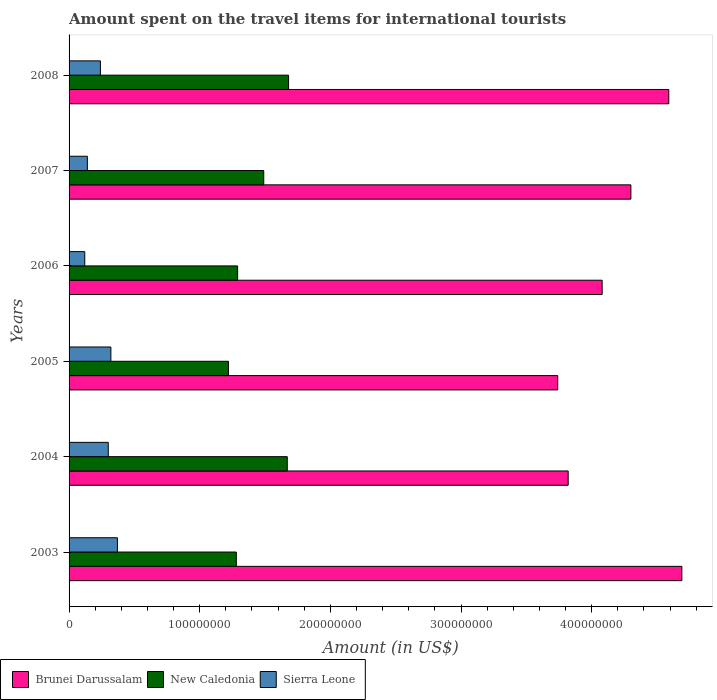How many groups of bars are there?
Provide a short and direct response. 6. How many bars are there on the 4th tick from the bottom?
Provide a succinct answer. 3. What is the amount spent on the travel items for international tourists in New Caledonia in 2006?
Keep it short and to the point. 1.29e+08. Across all years, what is the maximum amount spent on the travel items for international tourists in New Caledonia?
Keep it short and to the point. 1.68e+08. Across all years, what is the minimum amount spent on the travel items for international tourists in New Caledonia?
Make the answer very short. 1.22e+08. In which year was the amount spent on the travel items for international tourists in Sierra Leone minimum?
Your answer should be compact. 2006. What is the total amount spent on the travel items for international tourists in New Caledonia in the graph?
Offer a very short reply. 8.63e+08. What is the difference between the amount spent on the travel items for international tourists in Brunei Darussalam in 2003 and that in 2004?
Ensure brevity in your answer.  8.70e+07. What is the difference between the amount spent on the travel items for international tourists in New Caledonia in 2004 and the amount spent on the travel items for international tourists in Brunei Darussalam in 2003?
Offer a very short reply. -3.02e+08. What is the average amount spent on the travel items for international tourists in Brunei Darussalam per year?
Make the answer very short. 4.20e+08. In the year 2007, what is the difference between the amount spent on the travel items for international tourists in New Caledonia and amount spent on the travel items for international tourists in Brunei Darussalam?
Your answer should be very brief. -2.81e+08. What is the ratio of the amount spent on the travel items for international tourists in New Caledonia in 2006 to that in 2007?
Make the answer very short. 0.87. Is the amount spent on the travel items for international tourists in New Caledonia in 2005 less than that in 2006?
Make the answer very short. Yes. Is the difference between the amount spent on the travel items for international tourists in New Caledonia in 2006 and 2007 greater than the difference between the amount spent on the travel items for international tourists in Brunei Darussalam in 2006 and 2007?
Your answer should be compact. Yes. What is the difference between the highest and the lowest amount spent on the travel items for international tourists in Sierra Leone?
Keep it short and to the point. 2.50e+07. Is the sum of the amount spent on the travel items for international tourists in New Caledonia in 2007 and 2008 greater than the maximum amount spent on the travel items for international tourists in Brunei Darussalam across all years?
Your answer should be compact. No. What does the 3rd bar from the top in 2005 represents?
Ensure brevity in your answer.  Brunei Darussalam. What does the 1st bar from the bottom in 2003 represents?
Provide a succinct answer. Brunei Darussalam. Is it the case that in every year, the sum of the amount spent on the travel items for international tourists in Sierra Leone and amount spent on the travel items for international tourists in New Caledonia is greater than the amount spent on the travel items for international tourists in Brunei Darussalam?
Make the answer very short. No. Are the values on the major ticks of X-axis written in scientific E-notation?
Offer a very short reply. No. Does the graph contain any zero values?
Make the answer very short. No. Does the graph contain grids?
Provide a succinct answer. No. How many legend labels are there?
Keep it short and to the point. 3. What is the title of the graph?
Provide a short and direct response. Amount spent on the travel items for international tourists. What is the label or title of the X-axis?
Your response must be concise. Amount (in US$). What is the label or title of the Y-axis?
Ensure brevity in your answer.  Years. What is the Amount (in US$) in Brunei Darussalam in 2003?
Provide a succinct answer. 4.69e+08. What is the Amount (in US$) of New Caledonia in 2003?
Provide a short and direct response. 1.28e+08. What is the Amount (in US$) of Sierra Leone in 2003?
Make the answer very short. 3.70e+07. What is the Amount (in US$) in Brunei Darussalam in 2004?
Your answer should be very brief. 3.82e+08. What is the Amount (in US$) of New Caledonia in 2004?
Your response must be concise. 1.67e+08. What is the Amount (in US$) of Sierra Leone in 2004?
Your answer should be compact. 3.00e+07. What is the Amount (in US$) of Brunei Darussalam in 2005?
Your response must be concise. 3.74e+08. What is the Amount (in US$) in New Caledonia in 2005?
Your answer should be compact. 1.22e+08. What is the Amount (in US$) of Sierra Leone in 2005?
Ensure brevity in your answer.  3.20e+07. What is the Amount (in US$) in Brunei Darussalam in 2006?
Keep it short and to the point. 4.08e+08. What is the Amount (in US$) of New Caledonia in 2006?
Your response must be concise. 1.29e+08. What is the Amount (in US$) in Sierra Leone in 2006?
Your response must be concise. 1.20e+07. What is the Amount (in US$) in Brunei Darussalam in 2007?
Your response must be concise. 4.30e+08. What is the Amount (in US$) of New Caledonia in 2007?
Offer a terse response. 1.49e+08. What is the Amount (in US$) of Sierra Leone in 2007?
Offer a terse response. 1.40e+07. What is the Amount (in US$) of Brunei Darussalam in 2008?
Offer a terse response. 4.59e+08. What is the Amount (in US$) of New Caledonia in 2008?
Give a very brief answer. 1.68e+08. What is the Amount (in US$) of Sierra Leone in 2008?
Ensure brevity in your answer.  2.40e+07. Across all years, what is the maximum Amount (in US$) of Brunei Darussalam?
Ensure brevity in your answer.  4.69e+08. Across all years, what is the maximum Amount (in US$) of New Caledonia?
Your response must be concise. 1.68e+08. Across all years, what is the maximum Amount (in US$) of Sierra Leone?
Offer a very short reply. 3.70e+07. Across all years, what is the minimum Amount (in US$) of Brunei Darussalam?
Offer a very short reply. 3.74e+08. Across all years, what is the minimum Amount (in US$) of New Caledonia?
Provide a succinct answer. 1.22e+08. Across all years, what is the minimum Amount (in US$) of Sierra Leone?
Your answer should be very brief. 1.20e+07. What is the total Amount (in US$) in Brunei Darussalam in the graph?
Provide a short and direct response. 2.52e+09. What is the total Amount (in US$) in New Caledonia in the graph?
Offer a terse response. 8.63e+08. What is the total Amount (in US$) of Sierra Leone in the graph?
Keep it short and to the point. 1.49e+08. What is the difference between the Amount (in US$) of Brunei Darussalam in 2003 and that in 2004?
Offer a very short reply. 8.70e+07. What is the difference between the Amount (in US$) in New Caledonia in 2003 and that in 2004?
Ensure brevity in your answer.  -3.90e+07. What is the difference between the Amount (in US$) of Sierra Leone in 2003 and that in 2004?
Keep it short and to the point. 7.00e+06. What is the difference between the Amount (in US$) in Brunei Darussalam in 2003 and that in 2005?
Offer a very short reply. 9.50e+07. What is the difference between the Amount (in US$) of Brunei Darussalam in 2003 and that in 2006?
Provide a succinct answer. 6.10e+07. What is the difference between the Amount (in US$) in New Caledonia in 2003 and that in 2006?
Ensure brevity in your answer.  -1.00e+06. What is the difference between the Amount (in US$) of Sierra Leone in 2003 and that in 2006?
Offer a terse response. 2.50e+07. What is the difference between the Amount (in US$) of Brunei Darussalam in 2003 and that in 2007?
Offer a very short reply. 3.90e+07. What is the difference between the Amount (in US$) in New Caledonia in 2003 and that in 2007?
Make the answer very short. -2.10e+07. What is the difference between the Amount (in US$) of Sierra Leone in 2003 and that in 2007?
Your response must be concise. 2.30e+07. What is the difference between the Amount (in US$) of Brunei Darussalam in 2003 and that in 2008?
Offer a very short reply. 1.00e+07. What is the difference between the Amount (in US$) in New Caledonia in 2003 and that in 2008?
Your answer should be very brief. -4.00e+07. What is the difference between the Amount (in US$) of Sierra Leone in 2003 and that in 2008?
Your answer should be compact. 1.30e+07. What is the difference between the Amount (in US$) of Brunei Darussalam in 2004 and that in 2005?
Offer a terse response. 8.00e+06. What is the difference between the Amount (in US$) in New Caledonia in 2004 and that in 2005?
Give a very brief answer. 4.50e+07. What is the difference between the Amount (in US$) of Brunei Darussalam in 2004 and that in 2006?
Give a very brief answer. -2.60e+07. What is the difference between the Amount (in US$) in New Caledonia in 2004 and that in 2006?
Provide a succinct answer. 3.80e+07. What is the difference between the Amount (in US$) in Sierra Leone in 2004 and that in 2006?
Keep it short and to the point. 1.80e+07. What is the difference between the Amount (in US$) of Brunei Darussalam in 2004 and that in 2007?
Your response must be concise. -4.80e+07. What is the difference between the Amount (in US$) in New Caledonia in 2004 and that in 2007?
Offer a terse response. 1.80e+07. What is the difference between the Amount (in US$) of Sierra Leone in 2004 and that in 2007?
Offer a very short reply. 1.60e+07. What is the difference between the Amount (in US$) of Brunei Darussalam in 2004 and that in 2008?
Your answer should be compact. -7.70e+07. What is the difference between the Amount (in US$) in New Caledonia in 2004 and that in 2008?
Give a very brief answer. -1.00e+06. What is the difference between the Amount (in US$) of Sierra Leone in 2004 and that in 2008?
Make the answer very short. 6.00e+06. What is the difference between the Amount (in US$) in Brunei Darussalam in 2005 and that in 2006?
Provide a succinct answer. -3.40e+07. What is the difference between the Amount (in US$) in New Caledonia in 2005 and that in 2006?
Give a very brief answer. -7.00e+06. What is the difference between the Amount (in US$) in Sierra Leone in 2005 and that in 2006?
Your response must be concise. 2.00e+07. What is the difference between the Amount (in US$) in Brunei Darussalam in 2005 and that in 2007?
Your answer should be compact. -5.60e+07. What is the difference between the Amount (in US$) in New Caledonia in 2005 and that in 2007?
Offer a terse response. -2.70e+07. What is the difference between the Amount (in US$) of Sierra Leone in 2005 and that in 2007?
Ensure brevity in your answer.  1.80e+07. What is the difference between the Amount (in US$) in Brunei Darussalam in 2005 and that in 2008?
Offer a very short reply. -8.50e+07. What is the difference between the Amount (in US$) in New Caledonia in 2005 and that in 2008?
Give a very brief answer. -4.60e+07. What is the difference between the Amount (in US$) of Sierra Leone in 2005 and that in 2008?
Provide a short and direct response. 8.00e+06. What is the difference between the Amount (in US$) of Brunei Darussalam in 2006 and that in 2007?
Your answer should be compact. -2.20e+07. What is the difference between the Amount (in US$) in New Caledonia in 2006 and that in 2007?
Offer a terse response. -2.00e+07. What is the difference between the Amount (in US$) in Sierra Leone in 2006 and that in 2007?
Offer a terse response. -2.00e+06. What is the difference between the Amount (in US$) of Brunei Darussalam in 2006 and that in 2008?
Offer a very short reply. -5.10e+07. What is the difference between the Amount (in US$) in New Caledonia in 2006 and that in 2008?
Provide a short and direct response. -3.90e+07. What is the difference between the Amount (in US$) of Sierra Leone in 2006 and that in 2008?
Offer a terse response. -1.20e+07. What is the difference between the Amount (in US$) of Brunei Darussalam in 2007 and that in 2008?
Make the answer very short. -2.90e+07. What is the difference between the Amount (in US$) in New Caledonia in 2007 and that in 2008?
Provide a succinct answer. -1.90e+07. What is the difference between the Amount (in US$) of Sierra Leone in 2007 and that in 2008?
Give a very brief answer. -1.00e+07. What is the difference between the Amount (in US$) of Brunei Darussalam in 2003 and the Amount (in US$) of New Caledonia in 2004?
Provide a short and direct response. 3.02e+08. What is the difference between the Amount (in US$) in Brunei Darussalam in 2003 and the Amount (in US$) in Sierra Leone in 2004?
Keep it short and to the point. 4.39e+08. What is the difference between the Amount (in US$) of New Caledonia in 2003 and the Amount (in US$) of Sierra Leone in 2004?
Provide a short and direct response. 9.80e+07. What is the difference between the Amount (in US$) of Brunei Darussalam in 2003 and the Amount (in US$) of New Caledonia in 2005?
Provide a short and direct response. 3.47e+08. What is the difference between the Amount (in US$) in Brunei Darussalam in 2003 and the Amount (in US$) in Sierra Leone in 2005?
Keep it short and to the point. 4.37e+08. What is the difference between the Amount (in US$) in New Caledonia in 2003 and the Amount (in US$) in Sierra Leone in 2005?
Your answer should be compact. 9.60e+07. What is the difference between the Amount (in US$) in Brunei Darussalam in 2003 and the Amount (in US$) in New Caledonia in 2006?
Give a very brief answer. 3.40e+08. What is the difference between the Amount (in US$) in Brunei Darussalam in 2003 and the Amount (in US$) in Sierra Leone in 2006?
Make the answer very short. 4.57e+08. What is the difference between the Amount (in US$) in New Caledonia in 2003 and the Amount (in US$) in Sierra Leone in 2006?
Provide a short and direct response. 1.16e+08. What is the difference between the Amount (in US$) in Brunei Darussalam in 2003 and the Amount (in US$) in New Caledonia in 2007?
Provide a short and direct response. 3.20e+08. What is the difference between the Amount (in US$) of Brunei Darussalam in 2003 and the Amount (in US$) of Sierra Leone in 2007?
Offer a very short reply. 4.55e+08. What is the difference between the Amount (in US$) of New Caledonia in 2003 and the Amount (in US$) of Sierra Leone in 2007?
Provide a succinct answer. 1.14e+08. What is the difference between the Amount (in US$) of Brunei Darussalam in 2003 and the Amount (in US$) of New Caledonia in 2008?
Keep it short and to the point. 3.01e+08. What is the difference between the Amount (in US$) in Brunei Darussalam in 2003 and the Amount (in US$) in Sierra Leone in 2008?
Keep it short and to the point. 4.45e+08. What is the difference between the Amount (in US$) of New Caledonia in 2003 and the Amount (in US$) of Sierra Leone in 2008?
Your response must be concise. 1.04e+08. What is the difference between the Amount (in US$) in Brunei Darussalam in 2004 and the Amount (in US$) in New Caledonia in 2005?
Provide a succinct answer. 2.60e+08. What is the difference between the Amount (in US$) in Brunei Darussalam in 2004 and the Amount (in US$) in Sierra Leone in 2005?
Your answer should be very brief. 3.50e+08. What is the difference between the Amount (in US$) in New Caledonia in 2004 and the Amount (in US$) in Sierra Leone in 2005?
Make the answer very short. 1.35e+08. What is the difference between the Amount (in US$) in Brunei Darussalam in 2004 and the Amount (in US$) in New Caledonia in 2006?
Give a very brief answer. 2.53e+08. What is the difference between the Amount (in US$) of Brunei Darussalam in 2004 and the Amount (in US$) of Sierra Leone in 2006?
Give a very brief answer. 3.70e+08. What is the difference between the Amount (in US$) of New Caledonia in 2004 and the Amount (in US$) of Sierra Leone in 2006?
Your answer should be compact. 1.55e+08. What is the difference between the Amount (in US$) of Brunei Darussalam in 2004 and the Amount (in US$) of New Caledonia in 2007?
Offer a very short reply. 2.33e+08. What is the difference between the Amount (in US$) in Brunei Darussalam in 2004 and the Amount (in US$) in Sierra Leone in 2007?
Ensure brevity in your answer.  3.68e+08. What is the difference between the Amount (in US$) of New Caledonia in 2004 and the Amount (in US$) of Sierra Leone in 2007?
Make the answer very short. 1.53e+08. What is the difference between the Amount (in US$) in Brunei Darussalam in 2004 and the Amount (in US$) in New Caledonia in 2008?
Offer a very short reply. 2.14e+08. What is the difference between the Amount (in US$) of Brunei Darussalam in 2004 and the Amount (in US$) of Sierra Leone in 2008?
Provide a succinct answer. 3.58e+08. What is the difference between the Amount (in US$) in New Caledonia in 2004 and the Amount (in US$) in Sierra Leone in 2008?
Your answer should be very brief. 1.43e+08. What is the difference between the Amount (in US$) of Brunei Darussalam in 2005 and the Amount (in US$) of New Caledonia in 2006?
Ensure brevity in your answer.  2.45e+08. What is the difference between the Amount (in US$) in Brunei Darussalam in 2005 and the Amount (in US$) in Sierra Leone in 2006?
Offer a terse response. 3.62e+08. What is the difference between the Amount (in US$) in New Caledonia in 2005 and the Amount (in US$) in Sierra Leone in 2006?
Provide a short and direct response. 1.10e+08. What is the difference between the Amount (in US$) of Brunei Darussalam in 2005 and the Amount (in US$) of New Caledonia in 2007?
Your answer should be compact. 2.25e+08. What is the difference between the Amount (in US$) of Brunei Darussalam in 2005 and the Amount (in US$) of Sierra Leone in 2007?
Your response must be concise. 3.60e+08. What is the difference between the Amount (in US$) in New Caledonia in 2005 and the Amount (in US$) in Sierra Leone in 2007?
Your response must be concise. 1.08e+08. What is the difference between the Amount (in US$) in Brunei Darussalam in 2005 and the Amount (in US$) in New Caledonia in 2008?
Provide a succinct answer. 2.06e+08. What is the difference between the Amount (in US$) of Brunei Darussalam in 2005 and the Amount (in US$) of Sierra Leone in 2008?
Offer a very short reply. 3.50e+08. What is the difference between the Amount (in US$) in New Caledonia in 2005 and the Amount (in US$) in Sierra Leone in 2008?
Your answer should be compact. 9.80e+07. What is the difference between the Amount (in US$) of Brunei Darussalam in 2006 and the Amount (in US$) of New Caledonia in 2007?
Give a very brief answer. 2.59e+08. What is the difference between the Amount (in US$) of Brunei Darussalam in 2006 and the Amount (in US$) of Sierra Leone in 2007?
Keep it short and to the point. 3.94e+08. What is the difference between the Amount (in US$) in New Caledonia in 2006 and the Amount (in US$) in Sierra Leone in 2007?
Offer a terse response. 1.15e+08. What is the difference between the Amount (in US$) in Brunei Darussalam in 2006 and the Amount (in US$) in New Caledonia in 2008?
Provide a succinct answer. 2.40e+08. What is the difference between the Amount (in US$) in Brunei Darussalam in 2006 and the Amount (in US$) in Sierra Leone in 2008?
Your answer should be very brief. 3.84e+08. What is the difference between the Amount (in US$) of New Caledonia in 2006 and the Amount (in US$) of Sierra Leone in 2008?
Provide a short and direct response. 1.05e+08. What is the difference between the Amount (in US$) of Brunei Darussalam in 2007 and the Amount (in US$) of New Caledonia in 2008?
Ensure brevity in your answer.  2.62e+08. What is the difference between the Amount (in US$) of Brunei Darussalam in 2007 and the Amount (in US$) of Sierra Leone in 2008?
Your answer should be very brief. 4.06e+08. What is the difference between the Amount (in US$) in New Caledonia in 2007 and the Amount (in US$) in Sierra Leone in 2008?
Offer a terse response. 1.25e+08. What is the average Amount (in US$) of Brunei Darussalam per year?
Provide a succinct answer. 4.20e+08. What is the average Amount (in US$) in New Caledonia per year?
Your answer should be compact. 1.44e+08. What is the average Amount (in US$) in Sierra Leone per year?
Your answer should be very brief. 2.48e+07. In the year 2003, what is the difference between the Amount (in US$) of Brunei Darussalam and Amount (in US$) of New Caledonia?
Offer a very short reply. 3.41e+08. In the year 2003, what is the difference between the Amount (in US$) of Brunei Darussalam and Amount (in US$) of Sierra Leone?
Give a very brief answer. 4.32e+08. In the year 2003, what is the difference between the Amount (in US$) of New Caledonia and Amount (in US$) of Sierra Leone?
Make the answer very short. 9.10e+07. In the year 2004, what is the difference between the Amount (in US$) of Brunei Darussalam and Amount (in US$) of New Caledonia?
Keep it short and to the point. 2.15e+08. In the year 2004, what is the difference between the Amount (in US$) in Brunei Darussalam and Amount (in US$) in Sierra Leone?
Offer a terse response. 3.52e+08. In the year 2004, what is the difference between the Amount (in US$) in New Caledonia and Amount (in US$) in Sierra Leone?
Your answer should be very brief. 1.37e+08. In the year 2005, what is the difference between the Amount (in US$) of Brunei Darussalam and Amount (in US$) of New Caledonia?
Provide a short and direct response. 2.52e+08. In the year 2005, what is the difference between the Amount (in US$) of Brunei Darussalam and Amount (in US$) of Sierra Leone?
Keep it short and to the point. 3.42e+08. In the year 2005, what is the difference between the Amount (in US$) of New Caledonia and Amount (in US$) of Sierra Leone?
Provide a short and direct response. 9.00e+07. In the year 2006, what is the difference between the Amount (in US$) of Brunei Darussalam and Amount (in US$) of New Caledonia?
Provide a succinct answer. 2.79e+08. In the year 2006, what is the difference between the Amount (in US$) of Brunei Darussalam and Amount (in US$) of Sierra Leone?
Provide a succinct answer. 3.96e+08. In the year 2006, what is the difference between the Amount (in US$) of New Caledonia and Amount (in US$) of Sierra Leone?
Give a very brief answer. 1.17e+08. In the year 2007, what is the difference between the Amount (in US$) in Brunei Darussalam and Amount (in US$) in New Caledonia?
Keep it short and to the point. 2.81e+08. In the year 2007, what is the difference between the Amount (in US$) in Brunei Darussalam and Amount (in US$) in Sierra Leone?
Give a very brief answer. 4.16e+08. In the year 2007, what is the difference between the Amount (in US$) in New Caledonia and Amount (in US$) in Sierra Leone?
Offer a terse response. 1.35e+08. In the year 2008, what is the difference between the Amount (in US$) in Brunei Darussalam and Amount (in US$) in New Caledonia?
Provide a succinct answer. 2.91e+08. In the year 2008, what is the difference between the Amount (in US$) of Brunei Darussalam and Amount (in US$) of Sierra Leone?
Your response must be concise. 4.35e+08. In the year 2008, what is the difference between the Amount (in US$) of New Caledonia and Amount (in US$) of Sierra Leone?
Your answer should be very brief. 1.44e+08. What is the ratio of the Amount (in US$) of Brunei Darussalam in 2003 to that in 2004?
Your answer should be compact. 1.23. What is the ratio of the Amount (in US$) of New Caledonia in 2003 to that in 2004?
Ensure brevity in your answer.  0.77. What is the ratio of the Amount (in US$) of Sierra Leone in 2003 to that in 2004?
Offer a terse response. 1.23. What is the ratio of the Amount (in US$) of Brunei Darussalam in 2003 to that in 2005?
Make the answer very short. 1.25. What is the ratio of the Amount (in US$) of New Caledonia in 2003 to that in 2005?
Provide a succinct answer. 1.05. What is the ratio of the Amount (in US$) of Sierra Leone in 2003 to that in 2005?
Your response must be concise. 1.16. What is the ratio of the Amount (in US$) in Brunei Darussalam in 2003 to that in 2006?
Offer a terse response. 1.15. What is the ratio of the Amount (in US$) of Sierra Leone in 2003 to that in 2006?
Your response must be concise. 3.08. What is the ratio of the Amount (in US$) of Brunei Darussalam in 2003 to that in 2007?
Make the answer very short. 1.09. What is the ratio of the Amount (in US$) of New Caledonia in 2003 to that in 2007?
Your answer should be compact. 0.86. What is the ratio of the Amount (in US$) of Sierra Leone in 2003 to that in 2007?
Your answer should be very brief. 2.64. What is the ratio of the Amount (in US$) in Brunei Darussalam in 2003 to that in 2008?
Provide a short and direct response. 1.02. What is the ratio of the Amount (in US$) in New Caledonia in 2003 to that in 2008?
Make the answer very short. 0.76. What is the ratio of the Amount (in US$) in Sierra Leone in 2003 to that in 2008?
Your response must be concise. 1.54. What is the ratio of the Amount (in US$) of Brunei Darussalam in 2004 to that in 2005?
Your answer should be compact. 1.02. What is the ratio of the Amount (in US$) in New Caledonia in 2004 to that in 2005?
Offer a terse response. 1.37. What is the ratio of the Amount (in US$) in Brunei Darussalam in 2004 to that in 2006?
Ensure brevity in your answer.  0.94. What is the ratio of the Amount (in US$) in New Caledonia in 2004 to that in 2006?
Provide a short and direct response. 1.29. What is the ratio of the Amount (in US$) of Sierra Leone in 2004 to that in 2006?
Your answer should be compact. 2.5. What is the ratio of the Amount (in US$) in Brunei Darussalam in 2004 to that in 2007?
Your answer should be very brief. 0.89. What is the ratio of the Amount (in US$) in New Caledonia in 2004 to that in 2007?
Keep it short and to the point. 1.12. What is the ratio of the Amount (in US$) of Sierra Leone in 2004 to that in 2007?
Your answer should be compact. 2.14. What is the ratio of the Amount (in US$) in Brunei Darussalam in 2004 to that in 2008?
Give a very brief answer. 0.83. What is the ratio of the Amount (in US$) in New Caledonia in 2005 to that in 2006?
Offer a very short reply. 0.95. What is the ratio of the Amount (in US$) in Sierra Leone in 2005 to that in 2006?
Give a very brief answer. 2.67. What is the ratio of the Amount (in US$) in Brunei Darussalam in 2005 to that in 2007?
Give a very brief answer. 0.87. What is the ratio of the Amount (in US$) in New Caledonia in 2005 to that in 2007?
Keep it short and to the point. 0.82. What is the ratio of the Amount (in US$) of Sierra Leone in 2005 to that in 2007?
Your response must be concise. 2.29. What is the ratio of the Amount (in US$) of Brunei Darussalam in 2005 to that in 2008?
Make the answer very short. 0.81. What is the ratio of the Amount (in US$) of New Caledonia in 2005 to that in 2008?
Your response must be concise. 0.73. What is the ratio of the Amount (in US$) of Brunei Darussalam in 2006 to that in 2007?
Ensure brevity in your answer.  0.95. What is the ratio of the Amount (in US$) of New Caledonia in 2006 to that in 2007?
Provide a short and direct response. 0.87. What is the ratio of the Amount (in US$) of Sierra Leone in 2006 to that in 2007?
Your response must be concise. 0.86. What is the ratio of the Amount (in US$) in Brunei Darussalam in 2006 to that in 2008?
Provide a short and direct response. 0.89. What is the ratio of the Amount (in US$) of New Caledonia in 2006 to that in 2008?
Your answer should be very brief. 0.77. What is the ratio of the Amount (in US$) in Brunei Darussalam in 2007 to that in 2008?
Your answer should be compact. 0.94. What is the ratio of the Amount (in US$) of New Caledonia in 2007 to that in 2008?
Offer a terse response. 0.89. What is the ratio of the Amount (in US$) of Sierra Leone in 2007 to that in 2008?
Your answer should be compact. 0.58. What is the difference between the highest and the second highest Amount (in US$) in New Caledonia?
Make the answer very short. 1.00e+06. What is the difference between the highest and the lowest Amount (in US$) of Brunei Darussalam?
Keep it short and to the point. 9.50e+07. What is the difference between the highest and the lowest Amount (in US$) of New Caledonia?
Your answer should be very brief. 4.60e+07. What is the difference between the highest and the lowest Amount (in US$) in Sierra Leone?
Make the answer very short. 2.50e+07. 